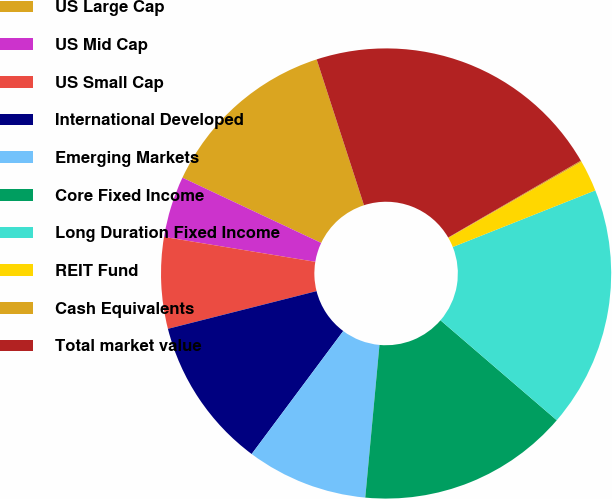<chart> <loc_0><loc_0><loc_500><loc_500><pie_chart><fcel>US Large Cap<fcel>US Mid Cap<fcel>US Small Cap<fcel>International Developed<fcel>Emerging Markets<fcel>Core Fixed Income<fcel>Long Duration Fixed Income<fcel>REIT Fund<fcel>Cash Equivalents<fcel>Total market value<nl><fcel>13.01%<fcel>4.4%<fcel>6.55%<fcel>10.86%<fcel>8.71%<fcel>15.17%<fcel>17.32%<fcel>2.25%<fcel>0.09%<fcel>21.63%<nl></chart> 